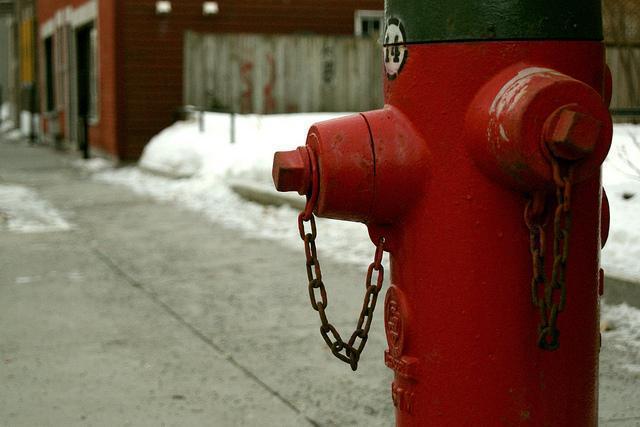How many chains are hanging from the fire hydrant?
Give a very brief answer. 2. 